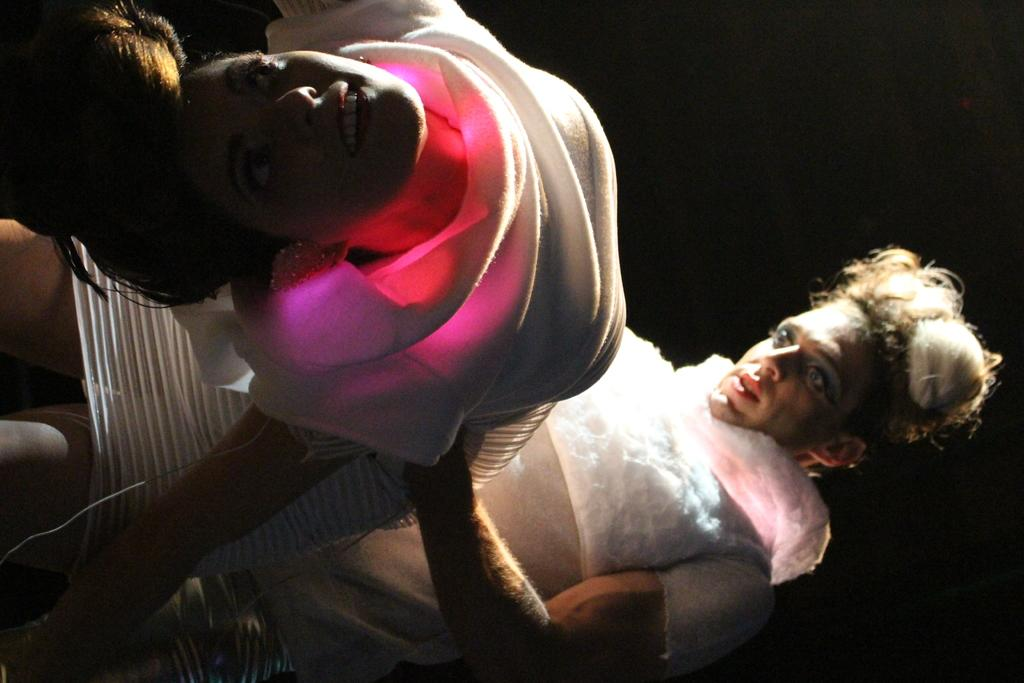What are the two people in the image doing? There is a man and a woman in the image, and the woman is in a bending position. What is the position of the man in the image? The man is standing on the floor. What is the position of the woman in the image? The woman is also standing on the floor, but she is in a bending position. What type of fan can be seen in the image? There is no fan present in the image. Is the image printed on a specific type of paper? The image itself is not a print, and there is no information about the type of paper it might be printed on. 